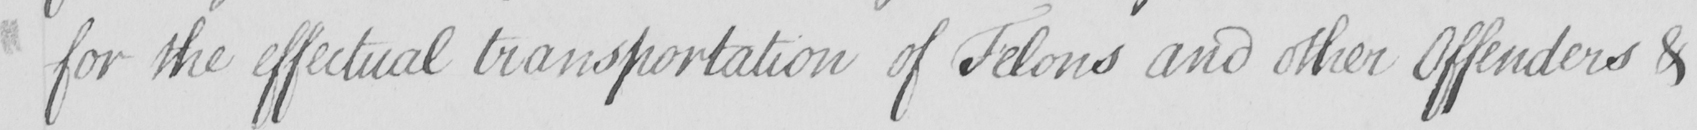Please transcribe the handwritten text in this image. for the effectual transportation of Felons and other Offenders & 